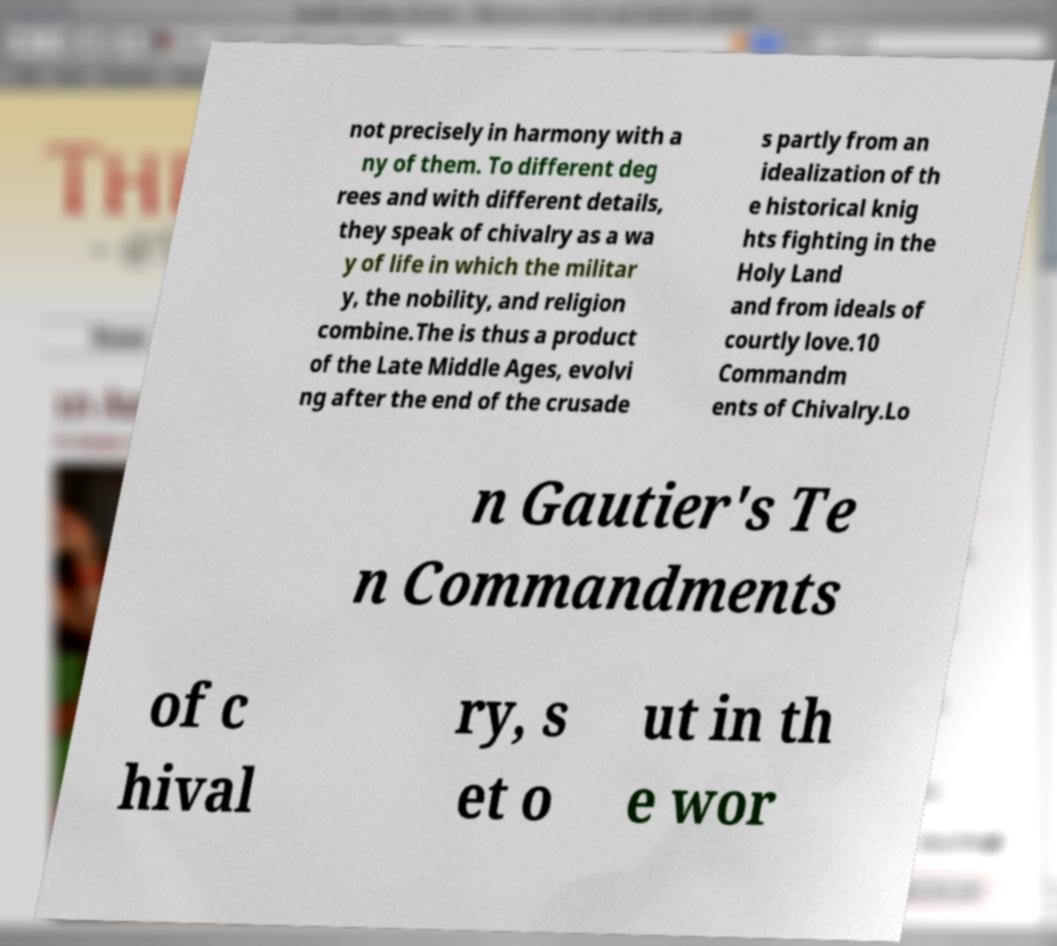What messages or text are displayed in this image? I need them in a readable, typed format. not precisely in harmony with a ny of them. To different deg rees and with different details, they speak of chivalry as a wa y of life in which the militar y, the nobility, and religion combine.The is thus a product of the Late Middle Ages, evolvi ng after the end of the crusade s partly from an idealization of th e historical knig hts fighting in the Holy Land and from ideals of courtly love.10 Commandm ents of Chivalry.Lo n Gautier's Te n Commandments of c hival ry, s et o ut in th e wor 